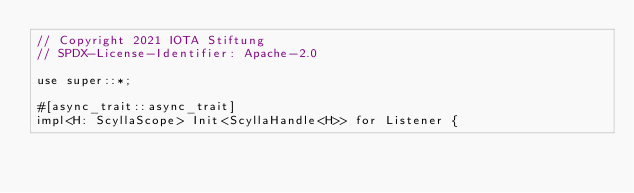Convert code to text. <code><loc_0><loc_0><loc_500><loc_500><_Rust_>// Copyright 2021 IOTA Stiftung
// SPDX-License-Identifier: Apache-2.0

use super::*;

#[async_trait::async_trait]
impl<H: ScyllaScope> Init<ScyllaHandle<H>> for Listener {</code> 